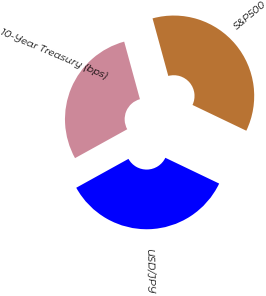Convert chart to OTSL. <chart><loc_0><loc_0><loc_500><loc_500><pie_chart><fcel>10-Year Treasury (bps)<fcel>S&P500<fcel>USD/JPY<nl><fcel>28.79%<fcel>36.36%<fcel>34.85%<nl></chart> 